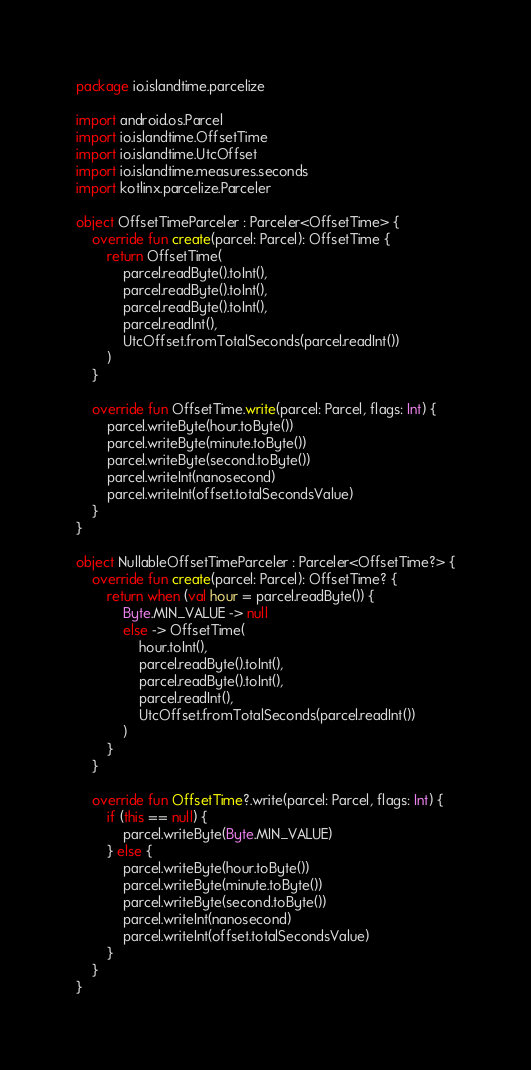Convert code to text. <code><loc_0><loc_0><loc_500><loc_500><_Kotlin_>package io.islandtime.parcelize

import android.os.Parcel
import io.islandtime.OffsetTime
import io.islandtime.UtcOffset
import io.islandtime.measures.seconds
import kotlinx.parcelize.Parceler

object OffsetTimeParceler : Parceler<OffsetTime> {
    override fun create(parcel: Parcel): OffsetTime {
        return OffsetTime(
            parcel.readByte().toInt(),
            parcel.readByte().toInt(),
            parcel.readByte().toInt(),
            parcel.readInt(),
            UtcOffset.fromTotalSeconds(parcel.readInt())
        )
    }

    override fun OffsetTime.write(parcel: Parcel, flags: Int) {
        parcel.writeByte(hour.toByte())
        parcel.writeByte(minute.toByte())
        parcel.writeByte(second.toByte())
        parcel.writeInt(nanosecond)
        parcel.writeInt(offset.totalSecondsValue)
    }
}

object NullableOffsetTimeParceler : Parceler<OffsetTime?> {
    override fun create(parcel: Parcel): OffsetTime? {
        return when (val hour = parcel.readByte()) {
            Byte.MIN_VALUE -> null
            else -> OffsetTime(
                hour.toInt(),
                parcel.readByte().toInt(),
                parcel.readByte().toInt(),
                parcel.readInt(),
                UtcOffset.fromTotalSeconds(parcel.readInt())
            )
        }
    }

    override fun OffsetTime?.write(parcel: Parcel, flags: Int) {
        if (this == null) {
            parcel.writeByte(Byte.MIN_VALUE)
        } else {
            parcel.writeByte(hour.toByte())
            parcel.writeByte(minute.toByte())
            parcel.writeByte(second.toByte())
            parcel.writeInt(nanosecond)
            parcel.writeInt(offset.totalSecondsValue)
        }
    }
}
</code> 